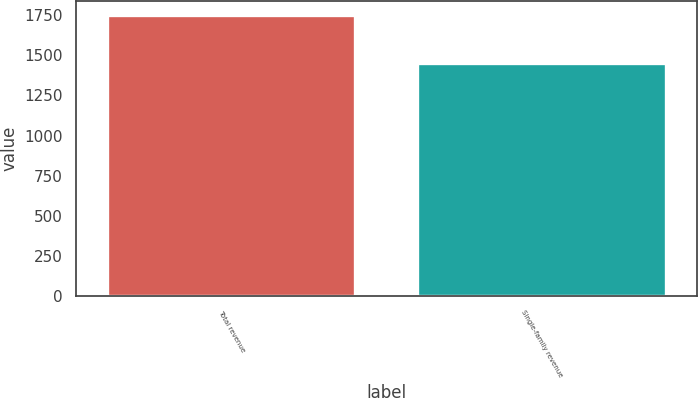Convert chart to OTSL. <chart><loc_0><loc_0><loc_500><loc_500><bar_chart><fcel>Total revenue<fcel>Single-family revenue<nl><fcel>1750<fcel>1455<nl></chart> 